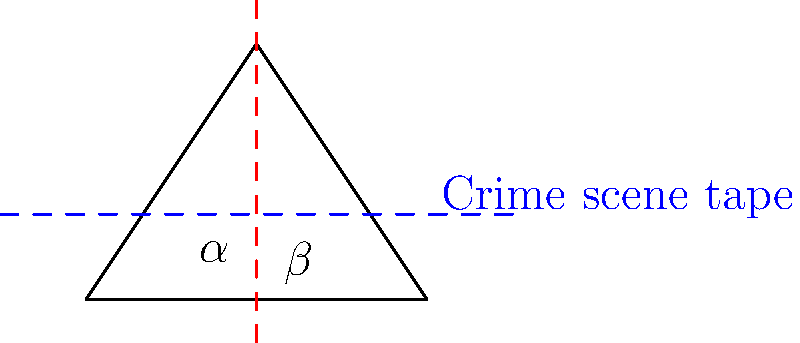At a grisly murder scene, two strips of crime scene tape intersect, forming four angles. If one of these angles measures $\alpha$ degrees and its adjacent angle measures $\beta$ degrees, what is the value of $\alpha + \beta$? Let's approach this step-by-step:

1) In the diagram, we see two intersecting lines (represented by the crime scene tape) forming four angles at the point of intersection.

2) When two straight lines intersect, they form two pairs of adjacent angles.

3) Adjacent angles are two angles that share a common vertex and a common side, but do not overlap.

4) A fundamental property of adjacent angles formed by intersecting lines is that they are supplementary, meaning they add up to 180°.

5) In this case, $\alpha$ and $\beta$ are adjacent angles, as they share a common vertex (the point of intersection) and a common side (the vertical red dashed line), but do not overlap.

6) Therefore, regardless of the individual measures of $\alpha$ and $\beta$, we know that:

   $\alpha + \beta = 180°$

This property holds true for any pair of adjacent angles formed by intersecting lines, which is why it's a crucial concept in crime scene reconstruction and spatial analysis.
Answer: $180°$ 